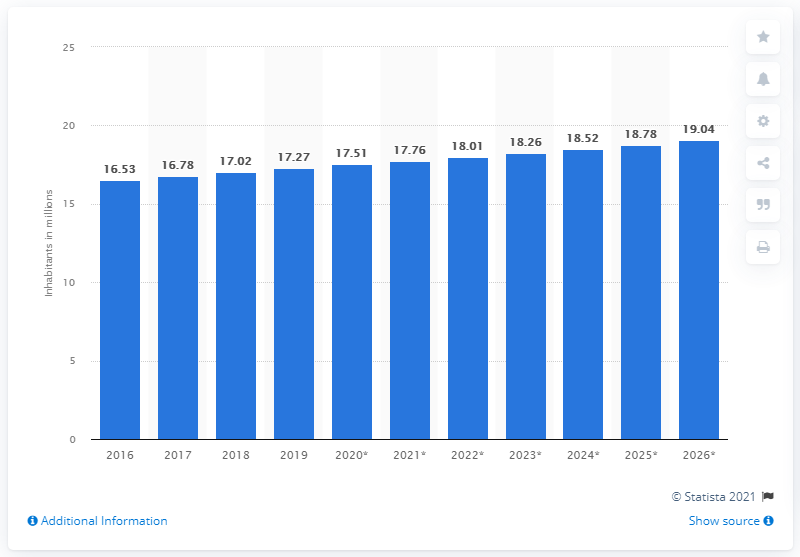Mention a couple of crucial points in this snapshot. In 2019, the population of Ecuador was 17.27 million. 